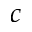<formula> <loc_0><loc_0><loc_500><loc_500>c</formula> 